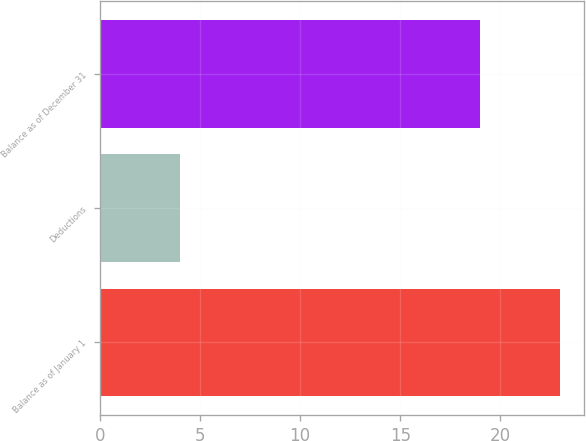Convert chart to OTSL. <chart><loc_0><loc_0><loc_500><loc_500><bar_chart><fcel>Balance as of January 1<fcel>Deductions<fcel>Balance as of December 31<nl><fcel>23<fcel>4<fcel>19<nl></chart> 